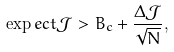Convert formula to latex. <formula><loc_0><loc_0><loc_500><loc_500>\exp e c t { \mathcal { J } } > B _ { c } + \frac { \Delta { \mathcal { J } } } { \sqrt { N } } ,</formula> 